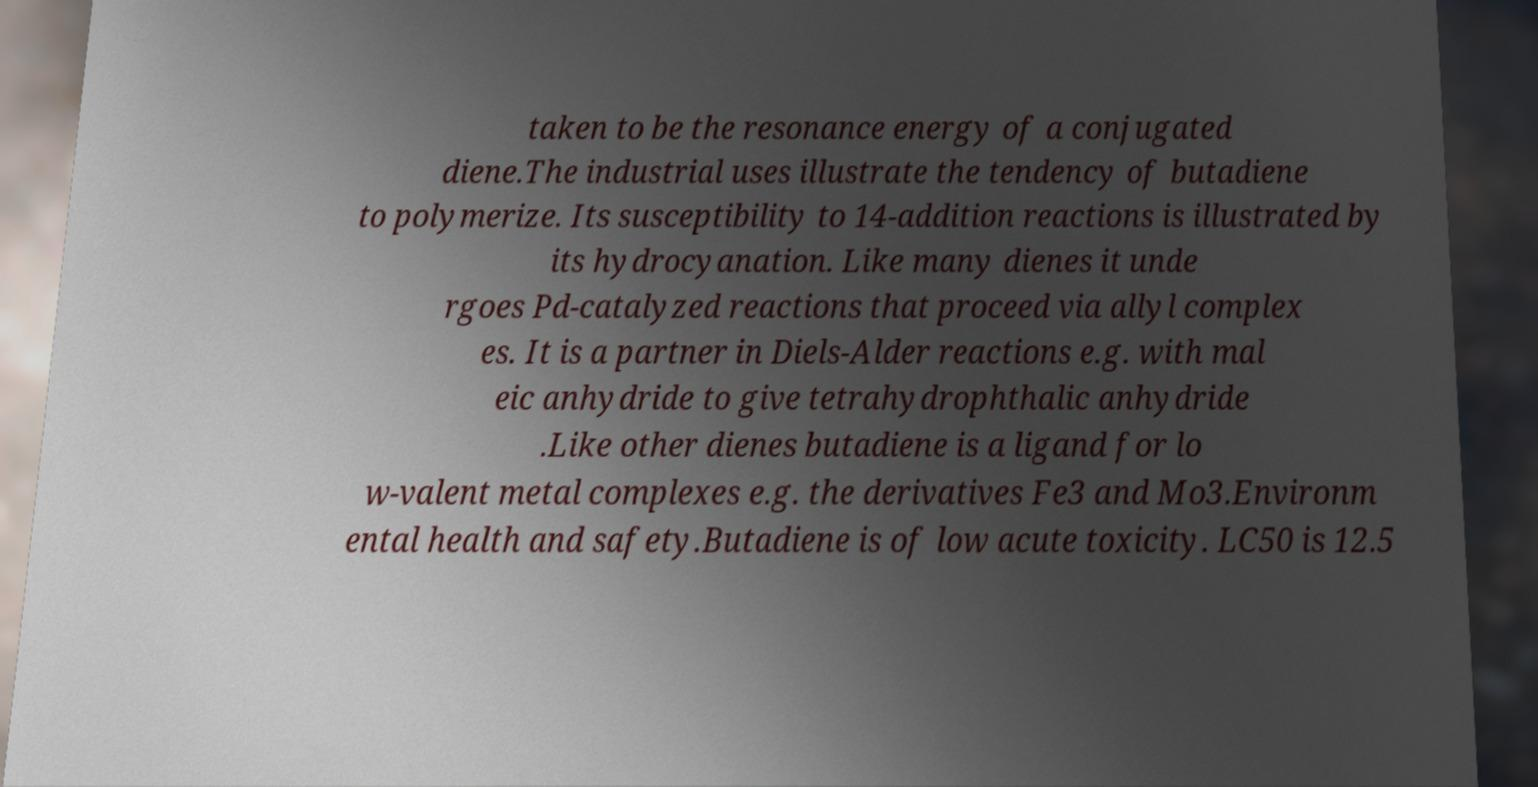Can you read and provide the text displayed in the image?This photo seems to have some interesting text. Can you extract and type it out for me? taken to be the resonance energy of a conjugated diene.The industrial uses illustrate the tendency of butadiene to polymerize. Its susceptibility to 14-addition reactions is illustrated by its hydrocyanation. Like many dienes it unde rgoes Pd-catalyzed reactions that proceed via allyl complex es. It is a partner in Diels-Alder reactions e.g. with mal eic anhydride to give tetrahydrophthalic anhydride .Like other dienes butadiene is a ligand for lo w-valent metal complexes e.g. the derivatives Fe3 and Mo3.Environm ental health and safety.Butadiene is of low acute toxicity. LC50 is 12.5 